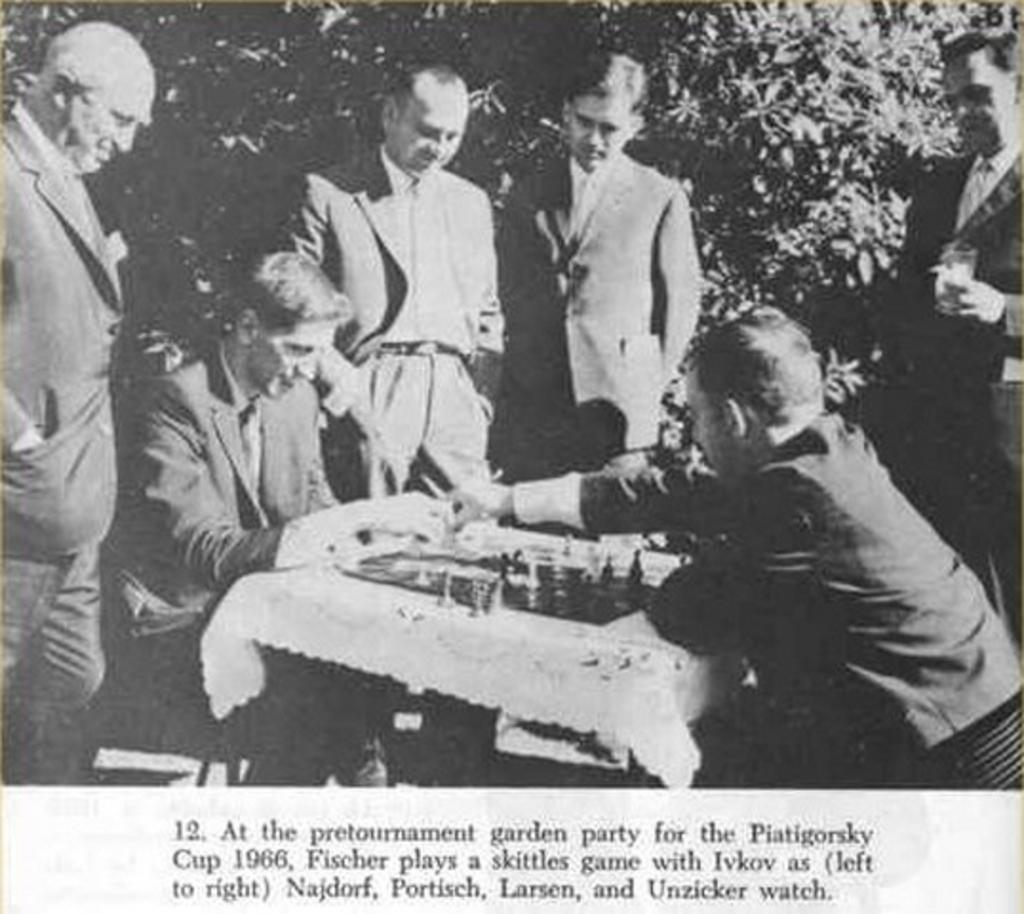What activity are the two persons in the image engaged in? The two persons in the image are playing chess. Are there any other people present in the image? Yes, there is a group of persons standing around the chess players. What can be seen in the background of the image? There are trees in the background of the image. What type of yam is being used as a chess piece in the image? There is no yam present in the image, and yams are not used as chess pieces. 